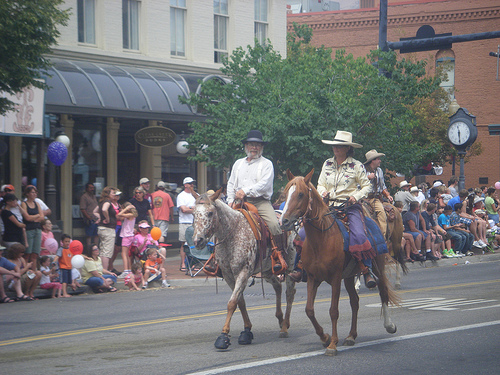<image>
Can you confirm if the clock is on the horse? No. The clock is not positioned on the horse. They may be near each other, but the clock is not supported by or resting on top of the horse. 